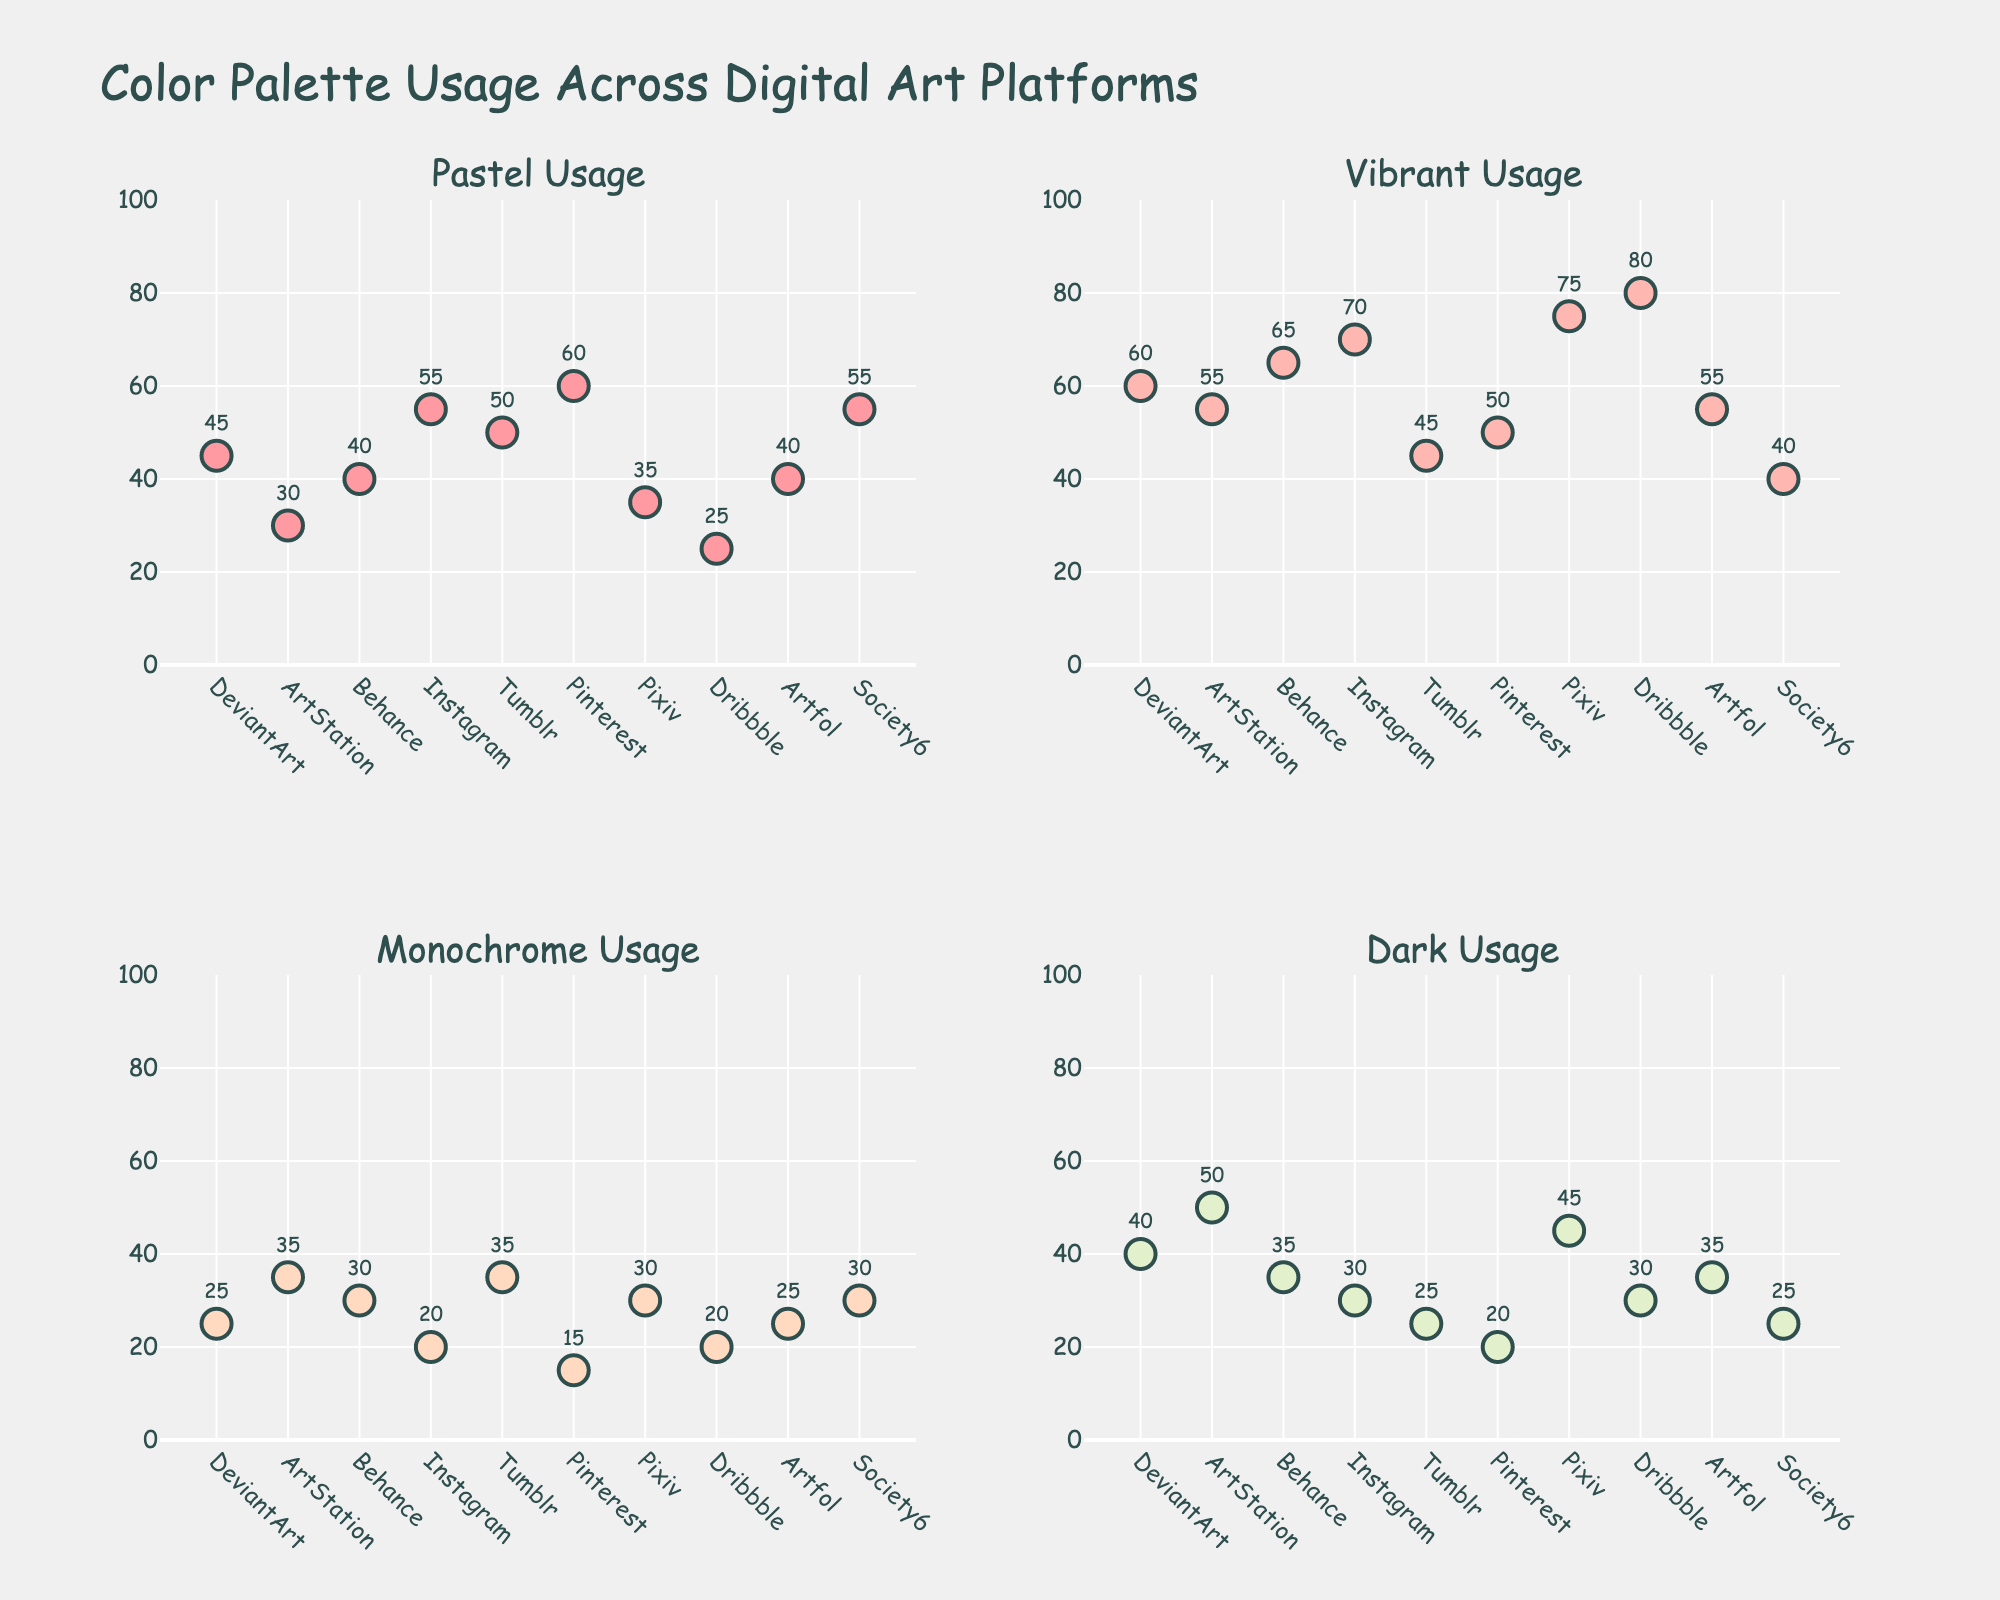How many variables are displayed in the scatterplot matrix? The scatterplot matrix includes work hours, leisure time, family time, stress levels, and job satisfaction as dimensions.
Answer: 5 What is the title of the scatterplot matrix? The title is displayed at the top of the scatterplot matrix.
Answer: Work-Life Balance Metrics Which variable is used for color-coding the scatterplot matrix? The figure uses color-coding based on the job satisfaction variable.
Answer: Job satisfaction How does leisure time relate to job satisfaction generally? By inspecting the scatter plots of leisure time and job satisfaction, data points with higher leisure time tend to have higher job satisfaction levels.
Answer: Positively correlated Who among the employees works the most hours, and what is their job satisfaction? Look for the point furthest right on the work hours axis. Christopher Martinez works the most hours, revealed by checking the color related to job satisfaction near that data point.
Answer: Christopher Martinez, job satisfaction 3 Which two metrics seem to have the strongest positive correlation? By visually examining the scatter plots, family time and leisure time data points cluster closely in an upward trend.
Answer: Family time and leisure time Is there an employee with both high stress level and high job satisfaction? By checking the high values on the stress level axis and looking for similar high value trends in job satisfaction, no such data point exists that combines both high stress and high job satisfaction.
Answer: No What is the range of job satisfaction scores depicted in the matrix? By examining the color scale legend on the scatterplot matrix, job satisfaction scores range from the lightest to the darkest color representing 3 to 9.
Answer: 3 to 9 Does work hours have any relation to stress level? By checking the scatter plot between work hours and stress level, there is a visible positive trend where increased work hours generally lead to higher stress levels.
Answer: Positively correlated 